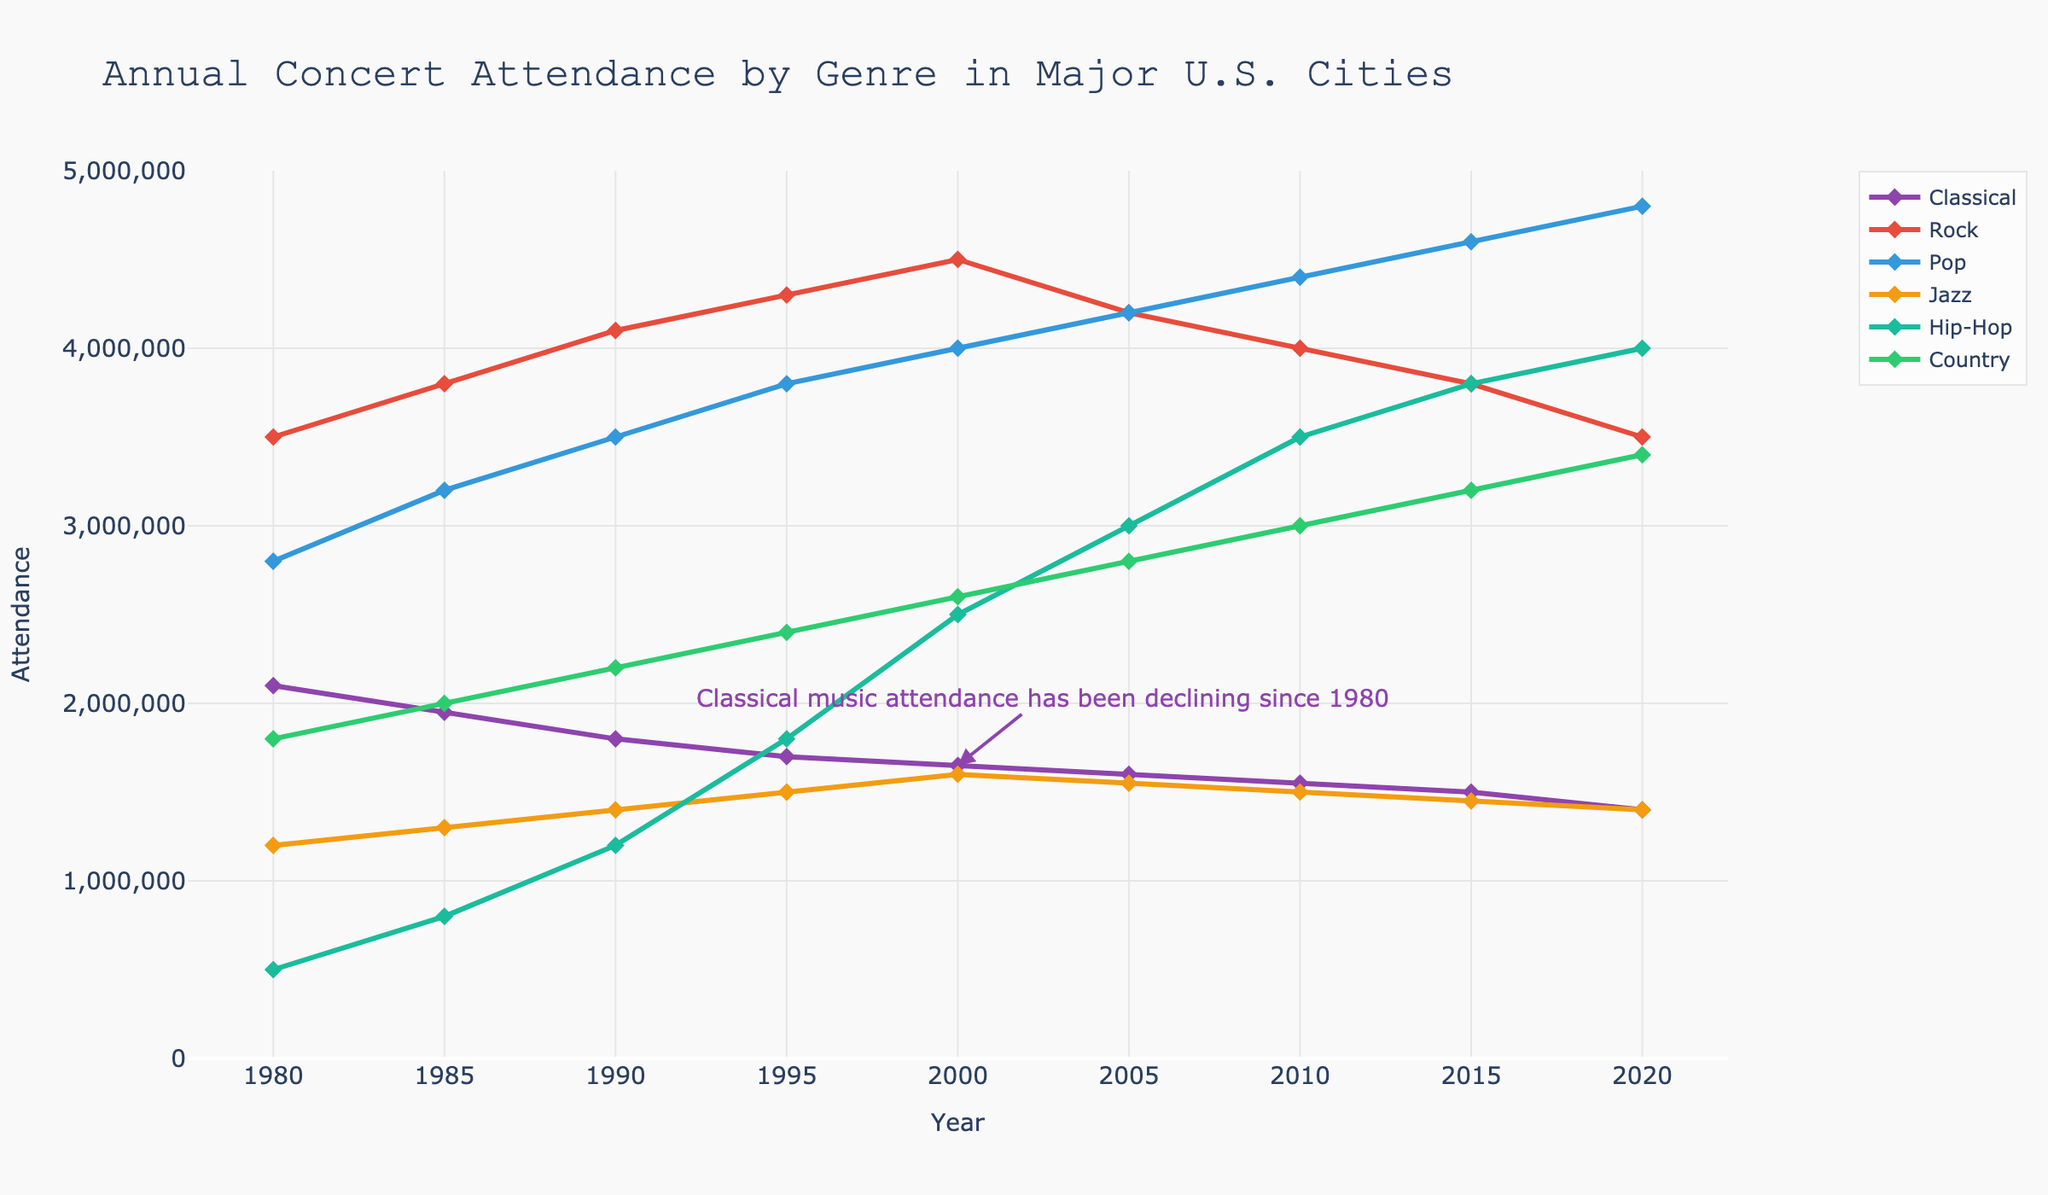What is the trend of classical music concert attendance since 1980? The attendance at classical music concerts has been consistently declining over the years. Starting at 2,100,000 in 1980, it has gradually decreased to 1,400,000 by 2020.
Answer: Decline Which genre had the highest attendance in 2020? In 2020, the Pop genre had the highest attendance among all genres. The plot shows that the attendance for Pop concerts reached 4,800,000.
Answer: Pop How does the attendance of Jazz concerts in 1995 compare to that in 2020? In 1995, the attendance at Jazz concerts was 1,500,000. By 2020, it decreased to 1,400,000. Therefore, there was a slight decline in Jazz concert attendance over this period.
Answer: Slight decline What is the attendance difference between Rock concerts and Classical concerts in 2000? In 2000, Rock concerts had an attendance of 4,500,000 while Classical concerts had 1,650,000. The difference is calculated as 4,500,000 - 1,650,000 = 2,850,000.
Answer: 2,850,000 Which genre showed the most significant increase in attendance from 1980 to 2020? Hip-Hop showed the most significant increase in attendance. The attendance grew from 500,000 in 1980 to 4,000,000 in 2020, a substantial rise of 3,500,000.
Answer: Hip-Hop What is the average attendance of Country music concerts between 1980 and 2020? The attendance figures for Country from 1980 to 2020 are: 1,800,000, 2,000,000, 2,200,000, 2,400,000, 2,600,000, 2,800,000, 3,000,000, 3,200,000, and 3,400,000. Summing these values gives 21,400,000. Dividing by the 9 data points, the average attendance is 21,400,000 / 9 ≈ 2,377,778.
Answer: Approximately 2,377,778 In which year did Rock concerts reach their highest attendance? Rock concerts reached their highest attendance in 2000 with a figure of 4,500,000.
Answer: 2000 By how much did the attendance of Hip-Hop concerts increase between 2000 and 2015? The attendance for Hip-Hop concerts in 2000 was 2,500,000 and increased to 3,800,000 by 2015. The increase is 3,800,000 - 2,500,000 = 1,300,000.
Answer: 1,300,000 